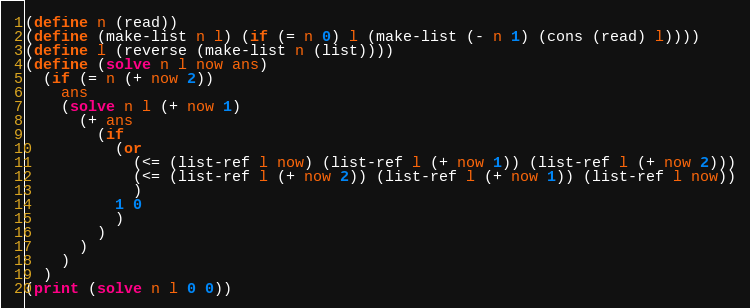Convert code to text. <code><loc_0><loc_0><loc_500><loc_500><_Scheme_>(define n (read))
(define (make-list n l) (if (= n 0) l (make-list (- n 1) (cons (read) l))))
(define l (reverse (make-list n (list))))
(define (solve n l now ans)
  (if (= n (+ now 2))
    ans
    (solve n l (+ now 1)
      (+ ans
        (if
          (or
            (<= (list-ref l now) (list-ref l (+ now 1)) (list-ref l (+ now 2)))
            (<= (list-ref l (+ now 2)) (list-ref l (+ now 1)) (list-ref l now))
            )
          1 0
          )
        )
      )
    )
  )
(print (solve n l 0 0))</code> 